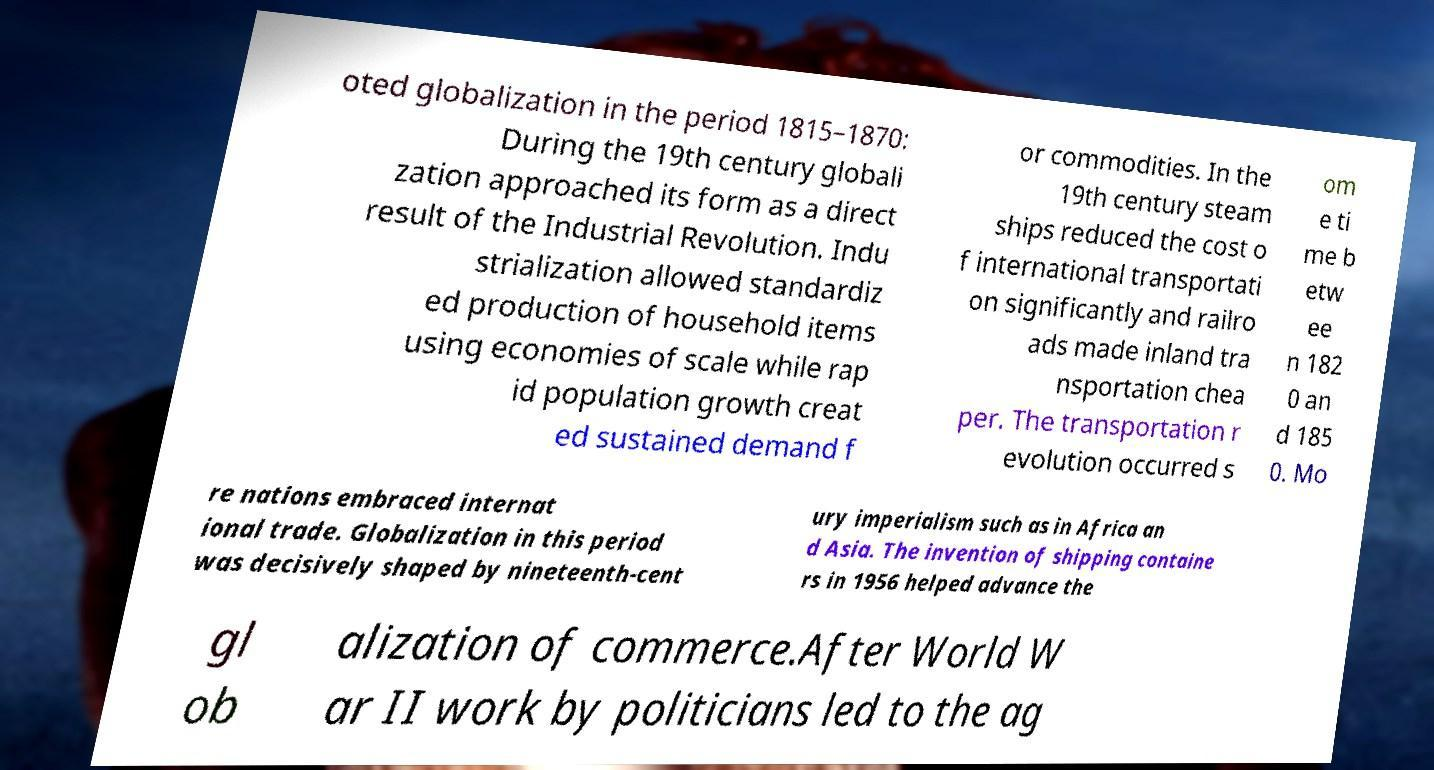Could you assist in decoding the text presented in this image and type it out clearly? oted globalization in the period 1815–1870: During the 19th century globali zation approached its form as a direct result of the Industrial Revolution. Indu strialization allowed standardiz ed production of household items using economies of scale while rap id population growth creat ed sustained demand f or commodities. In the 19th century steam ships reduced the cost o f international transportati on significantly and railro ads made inland tra nsportation chea per. The transportation r evolution occurred s om e ti me b etw ee n 182 0 an d 185 0. Mo re nations embraced internat ional trade. Globalization in this period was decisively shaped by nineteenth-cent ury imperialism such as in Africa an d Asia. The invention of shipping containe rs in 1956 helped advance the gl ob alization of commerce.After World W ar II work by politicians led to the ag 